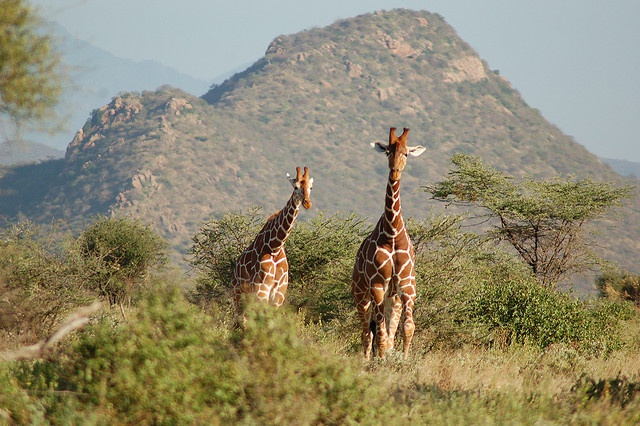Describe the objects in this image and their specific colors. I can see giraffe in olive, black, maroon, brown, and tan tones and giraffe in olive, black, tan, and maroon tones in this image. 